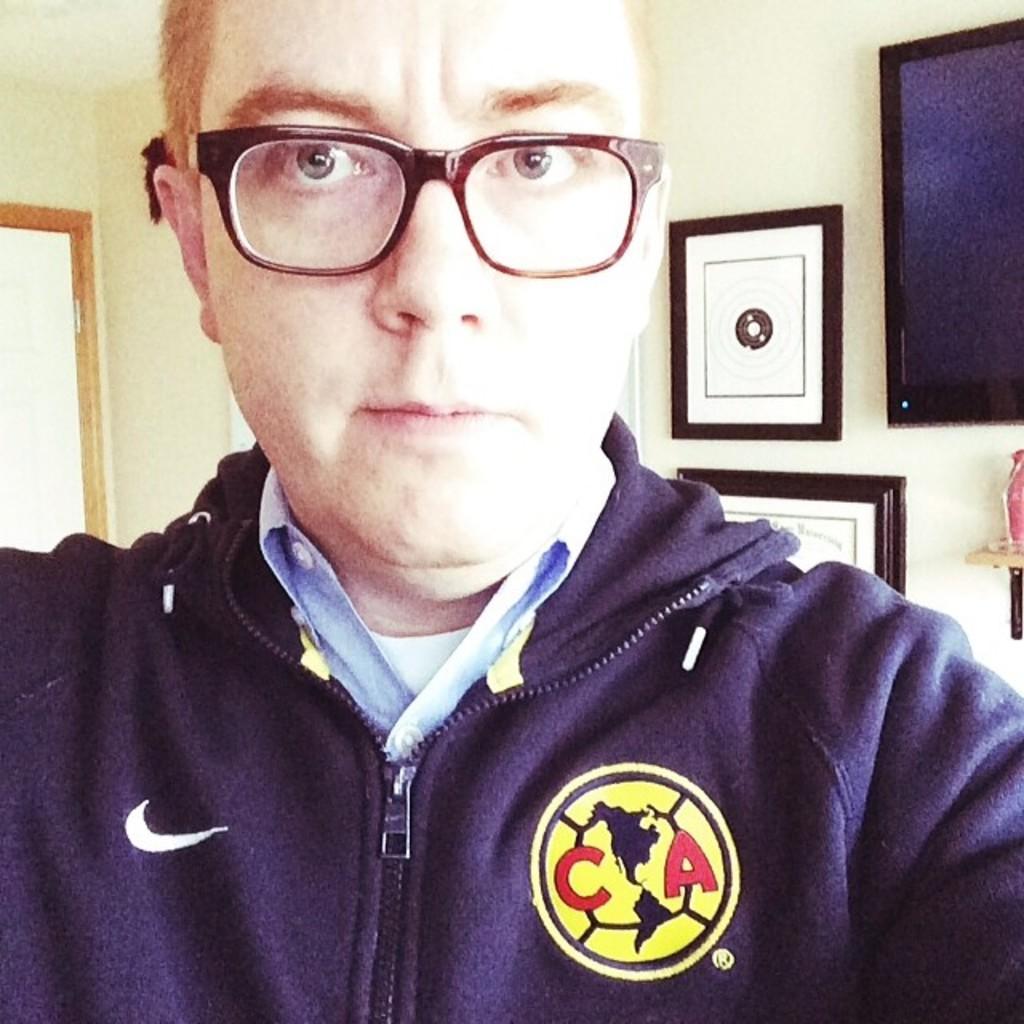Can you describe this image briefly? In this image we can see a person wearing spectacles, behind him we can see the door and some objects on the wall, we can see a black color object which looks like a television. 